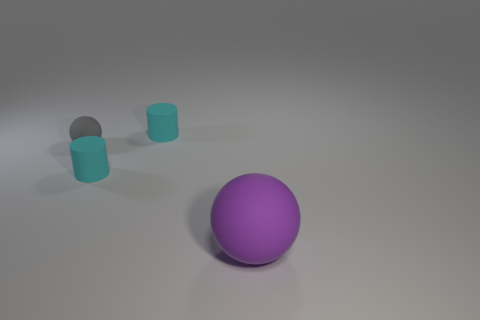Add 1 tiny things. How many objects exist? 5 Subtract all red balls. Subtract all blue cylinders. How many balls are left? 2 Add 4 cyan balls. How many cyan balls exist? 4 Subtract 0 red balls. How many objects are left? 4 Subtract all rubber cylinders. Subtract all large rubber balls. How many objects are left? 1 Add 2 gray matte spheres. How many gray matte spheres are left? 3 